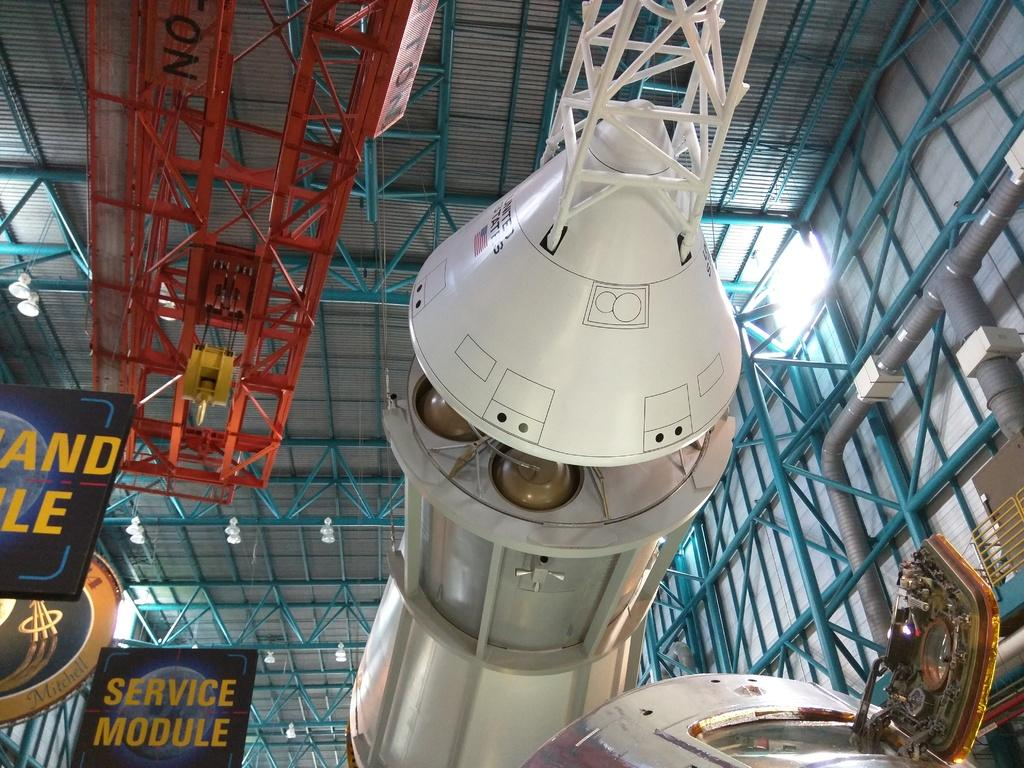<image>
Render a clear and concise summary of the photo. A space ship in a museum that has a sign that says Service Module. 